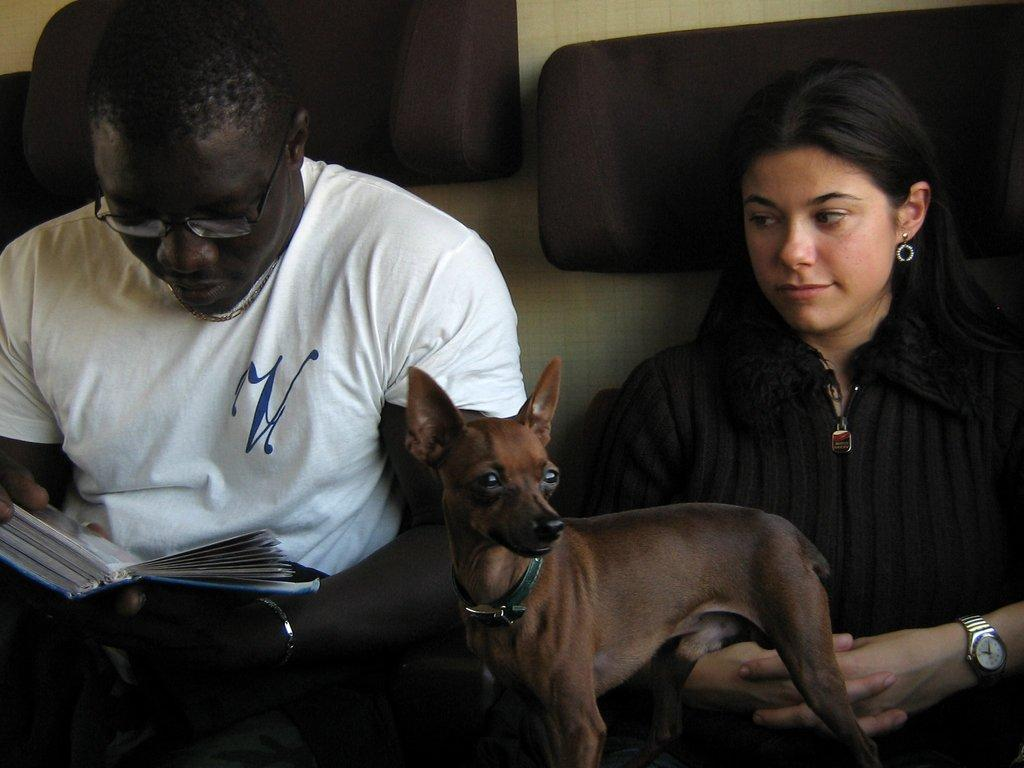What animal is at the bottom of the image? There is a duck at the bottom of the image. What are the two persons doing in the middle of the image? Two persons are sitting in the middle of the image. What is one of the persons holding? One of the persons is holding a book. What can be seen in the background of the image? There is a wall in the background of the image. What type of wound can be seen on the duck in the image? There is no wound visible on the duck in the image. Is the person holding the book wearing a scarf in the image? The provided facts do not mention a scarf, so we cannot determine if the person is wearing one. 